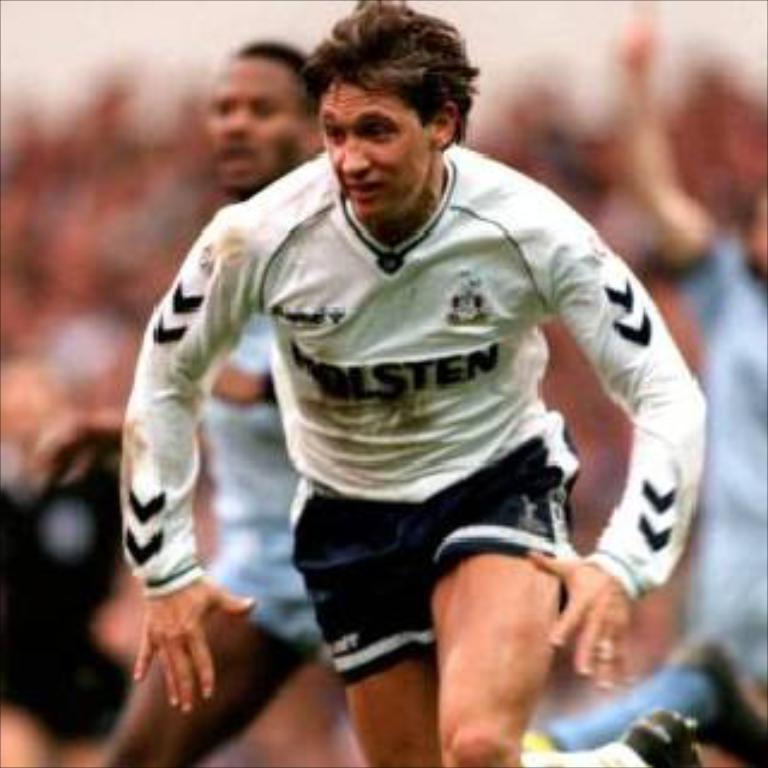What is the main action being performed by the person in the image? There is a person running in the image. Can you describe the people behind the running person? There are people visible behind the running person. What type of bomb can be seen in the alley behind the running person? There is no bomb or alley present in the image; it only shows a person running with people visible behind them. 